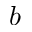<formula> <loc_0><loc_0><loc_500><loc_500>b</formula> 